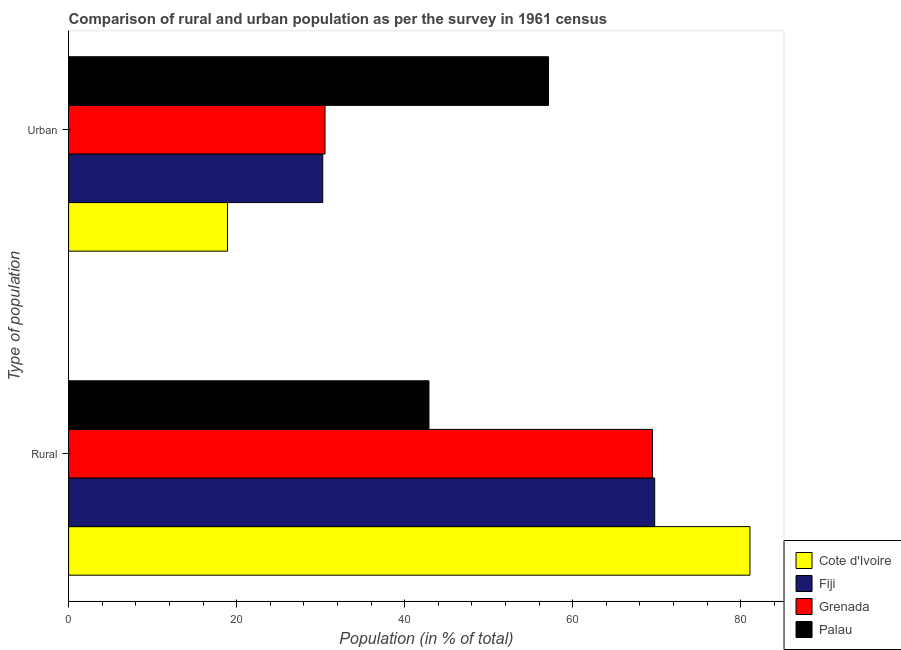How many groups of bars are there?
Make the answer very short. 2. Are the number of bars per tick equal to the number of legend labels?
Ensure brevity in your answer.  Yes. Are the number of bars on each tick of the Y-axis equal?
Your answer should be very brief. Yes. How many bars are there on the 1st tick from the top?
Offer a terse response. 4. How many bars are there on the 1st tick from the bottom?
Offer a terse response. 4. What is the label of the 2nd group of bars from the top?
Keep it short and to the point. Rural. What is the urban population in Cote d'Ivoire?
Offer a very short reply. 18.91. Across all countries, what is the maximum rural population?
Provide a short and direct response. 81.09. Across all countries, what is the minimum urban population?
Your answer should be compact. 18.91. In which country was the rural population maximum?
Keep it short and to the point. Cote d'Ivoire. In which country was the urban population minimum?
Give a very brief answer. Cote d'Ivoire. What is the total urban population in the graph?
Your answer should be compact. 136.79. What is the difference between the urban population in Palau and that in Cote d'Ivoire?
Give a very brief answer. 38.2. What is the difference between the urban population in Cote d'Ivoire and the rural population in Palau?
Offer a terse response. -23.98. What is the average rural population per country?
Your response must be concise. 65.8. What is the difference between the urban population and rural population in Palau?
Offer a terse response. 14.23. What is the ratio of the urban population in Cote d'Ivoire to that in Grenada?
Your answer should be very brief. 0.62. Is the rural population in Cote d'Ivoire less than that in Palau?
Offer a very short reply. No. In how many countries, is the urban population greater than the average urban population taken over all countries?
Provide a short and direct response. 1. What does the 3rd bar from the top in Rural represents?
Ensure brevity in your answer.  Fiji. What does the 4th bar from the bottom in Rural represents?
Ensure brevity in your answer.  Palau. Are all the bars in the graph horizontal?
Ensure brevity in your answer.  Yes. What is the difference between two consecutive major ticks on the X-axis?
Ensure brevity in your answer.  20. Are the values on the major ticks of X-axis written in scientific E-notation?
Ensure brevity in your answer.  No. Does the graph contain grids?
Make the answer very short. No. What is the title of the graph?
Give a very brief answer. Comparison of rural and urban population as per the survey in 1961 census. Does "France" appear as one of the legend labels in the graph?
Give a very brief answer. No. What is the label or title of the X-axis?
Your response must be concise. Population (in % of total). What is the label or title of the Y-axis?
Provide a short and direct response. Type of population. What is the Population (in % of total) of Cote d'Ivoire in Rural?
Provide a short and direct response. 81.09. What is the Population (in % of total) in Fiji in Rural?
Your response must be concise. 69.75. What is the Population (in % of total) in Grenada in Rural?
Offer a very short reply. 69.48. What is the Population (in % of total) of Palau in Rural?
Your response must be concise. 42.89. What is the Population (in % of total) of Cote d'Ivoire in Urban?
Make the answer very short. 18.91. What is the Population (in % of total) in Fiji in Urban?
Ensure brevity in your answer.  30.25. What is the Population (in % of total) in Grenada in Urban?
Provide a succinct answer. 30.52. What is the Population (in % of total) in Palau in Urban?
Ensure brevity in your answer.  57.11. Across all Type of population, what is the maximum Population (in % of total) of Cote d'Ivoire?
Your answer should be compact. 81.09. Across all Type of population, what is the maximum Population (in % of total) in Fiji?
Make the answer very short. 69.75. Across all Type of population, what is the maximum Population (in % of total) of Grenada?
Keep it short and to the point. 69.48. Across all Type of population, what is the maximum Population (in % of total) in Palau?
Offer a very short reply. 57.11. Across all Type of population, what is the minimum Population (in % of total) in Cote d'Ivoire?
Offer a terse response. 18.91. Across all Type of population, what is the minimum Population (in % of total) of Fiji?
Offer a terse response. 30.25. Across all Type of population, what is the minimum Population (in % of total) of Grenada?
Your answer should be very brief. 30.52. Across all Type of population, what is the minimum Population (in % of total) of Palau?
Offer a very short reply. 42.89. What is the total Population (in % of total) in Cote d'Ivoire in the graph?
Your answer should be very brief. 100. What is the total Population (in % of total) in Fiji in the graph?
Provide a short and direct response. 100. What is the total Population (in % of total) in Grenada in the graph?
Make the answer very short. 100. What is the difference between the Population (in % of total) of Cote d'Ivoire in Rural and that in Urban?
Your answer should be very brief. 62.18. What is the difference between the Population (in % of total) in Fiji in Rural and that in Urban?
Ensure brevity in your answer.  39.5. What is the difference between the Population (in % of total) of Grenada in Rural and that in Urban?
Offer a very short reply. 38.96. What is the difference between the Population (in % of total) in Palau in Rural and that in Urban?
Your answer should be compact. -14.23. What is the difference between the Population (in % of total) in Cote d'Ivoire in Rural and the Population (in % of total) in Fiji in Urban?
Give a very brief answer. 50.84. What is the difference between the Population (in % of total) in Cote d'Ivoire in Rural and the Population (in % of total) in Grenada in Urban?
Ensure brevity in your answer.  50.57. What is the difference between the Population (in % of total) of Cote d'Ivoire in Rural and the Population (in % of total) of Palau in Urban?
Make the answer very short. 23.98. What is the difference between the Population (in % of total) in Fiji in Rural and the Population (in % of total) in Grenada in Urban?
Ensure brevity in your answer.  39.23. What is the difference between the Population (in % of total) of Fiji in Rural and the Population (in % of total) of Palau in Urban?
Offer a terse response. 12.64. What is the difference between the Population (in % of total) in Grenada in Rural and the Population (in % of total) in Palau in Urban?
Your response must be concise. 12.37. What is the average Population (in % of total) in Grenada per Type of population?
Your answer should be very brief. 50. What is the difference between the Population (in % of total) of Cote d'Ivoire and Population (in % of total) of Fiji in Rural?
Offer a very short reply. 11.34. What is the difference between the Population (in % of total) in Cote d'Ivoire and Population (in % of total) in Grenada in Rural?
Offer a terse response. 11.61. What is the difference between the Population (in % of total) in Cote d'Ivoire and Population (in % of total) in Palau in Rural?
Ensure brevity in your answer.  38.2. What is the difference between the Population (in % of total) in Fiji and Population (in % of total) in Grenada in Rural?
Offer a very short reply. 0.27. What is the difference between the Population (in % of total) of Fiji and Population (in % of total) of Palau in Rural?
Give a very brief answer. 26.87. What is the difference between the Population (in % of total) in Grenada and Population (in % of total) in Palau in Rural?
Keep it short and to the point. 26.59. What is the difference between the Population (in % of total) in Cote d'Ivoire and Population (in % of total) in Fiji in Urban?
Offer a terse response. -11.34. What is the difference between the Population (in % of total) in Cote d'Ivoire and Population (in % of total) in Grenada in Urban?
Offer a terse response. -11.61. What is the difference between the Population (in % of total) in Cote d'Ivoire and Population (in % of total) in Palau in Urban?
Offer a terse response. -38.2. What is the difference between the Population (in % of total) in Fiji and Population (in % of total) in Grenada in Urban?
Give a very brief answer. -0.27. What is the difference between the Population (in % of total) of Fiji and Population (in % of total) of Palau in Urban?
Give a very brief answer. -26.87. What is the difference between the Population (in % of total) of Grenada and Population (in % of total) of Palau in Urban?
Provide a short and direct response. -26.59. What is the ratio of the Population (in % of total) in Cote d'Ivoire in Rural to that in Urban?
Provide a short and direct response. 4.29. What is the ratio of the Population (in % of total) of Fiji in Rural to that in Urban?
Ensure brevity in your answer.  2.31. What is the ratio of the Population (in % of total) of Grenada in Rural to that in Urban?
Provide a succinct answer. 2.28. What is the ratio of the Population (in % of total) in Palau in Rural to that in Urban?
Provide a short and direct response. 0.75. What is the difference between the highest and the second highest Population (in % of total) in Cote d'Ivoire?
Offer a very short reply. 62.18. What is the difference between the highest and the second highest Population (in % of total) in Fiji?
Offer a very short reply. 39.5. What is the difference between the highest and the second highest Population (in % of total) of Grenada?
Keep it short and to the point. 38.96. What is the difference between the highest and the second highest Population (in % of total) in Palau?
Provide a short and direct response. 14.23. What is the difference between the highest and the lowest Population (in % of total) of Cote d'Ivoire?
Ensure brevity in your answer.  62.18. What is the difference between the highest and the lowest Population (in % of total) of Fiji?
Your response must be concise. 39.5. What is the difference between the highest and the lowest Population (in % of total) of Grenada?
Your answer should be very brief. 38.96. What is the difference between the highest and the lowest Population (in % of total) in Palau?
Give a very brief answer. 14.23. 